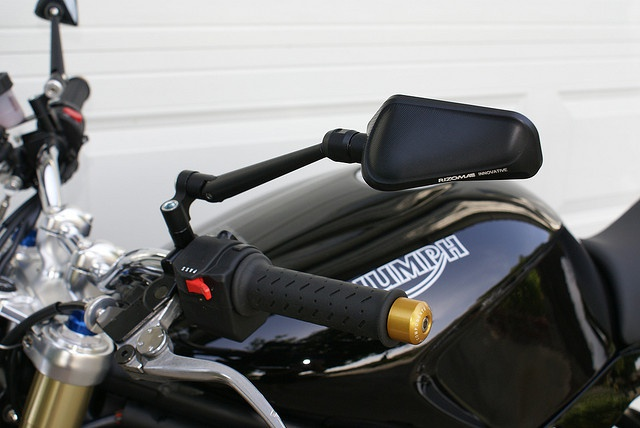Describe the objects in this image and their specific colors. I can see a motorcycle in lightgray, black, gray, and darkgray tones in this image. 